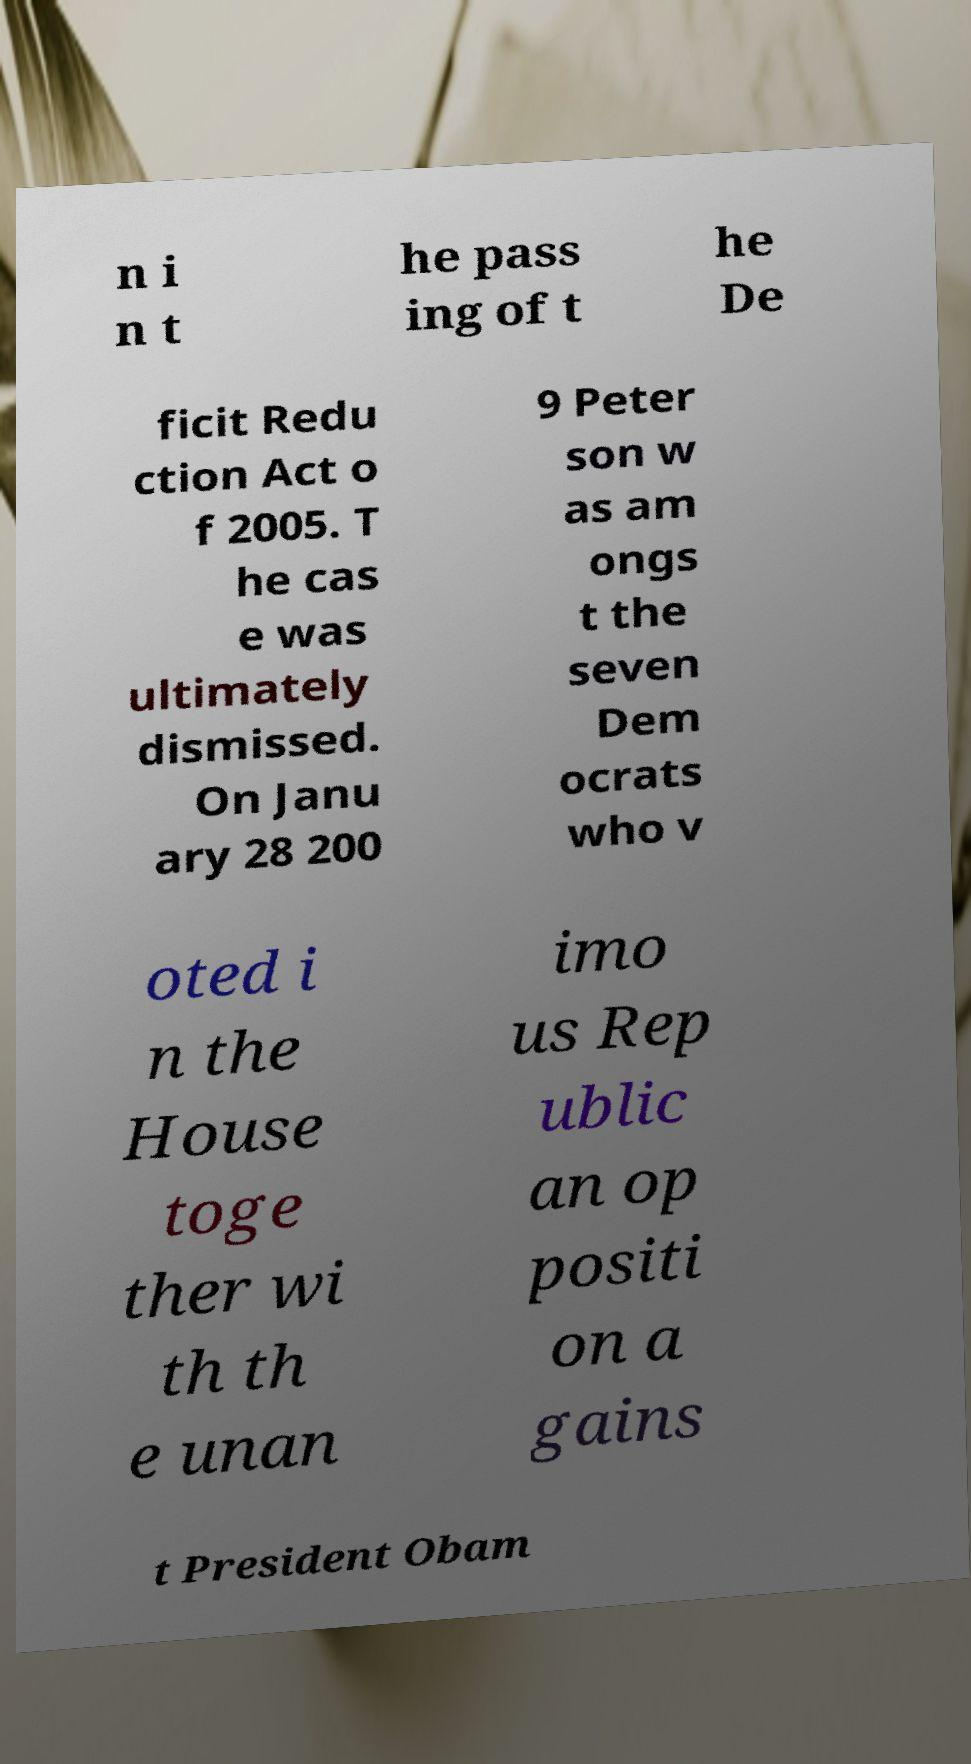What messages or text are displayed in this image? I need them in a readable, typed format. n i n t he pass ing of t he De ficit Redu ction Act o f 2005. T he cas e was ultimately dismissed. On Janu ary 28 200 9 Peter son w as am ongs t the seven Dem ocrats who v oted i n the House toge ther wi th th e unan imo us Rep ublic an op positi on a gains t President Obam 